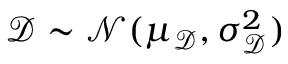Convert formula to latex. <formula><loc_0><loc_0><loc_500><loc_500>\ m a t h s c r D \sim \mathcal { N } ( \mu _ { \ m a t h s c r D } , \sigma _ { \ m a t h s c r D } ^ { 2 } )</formula> 